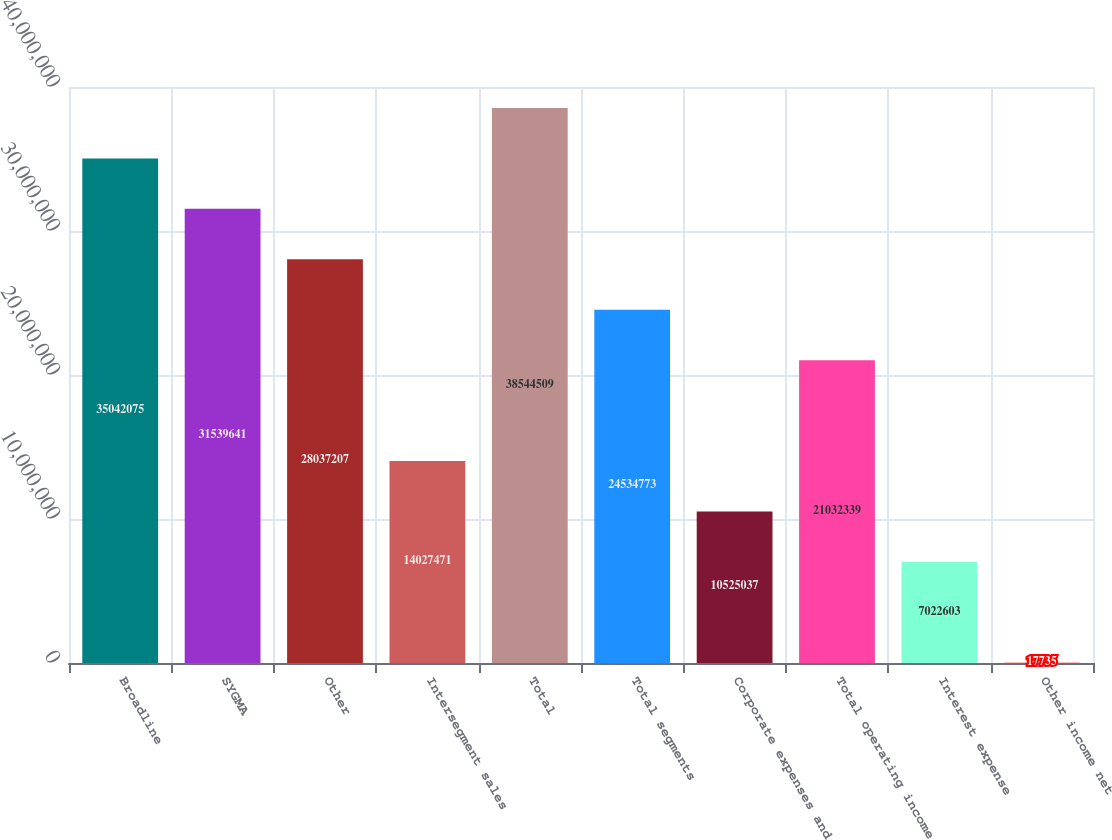<chart> <loc_0><loc_0><loc_500><loc_500><bar_chart><fcel>Broadline<fcel>SYGMA<fcel>Other<fcel>Intersegment sales<fcel>Total<fcel>Total segments<fcel>Corporate expenses and<fcel>Total operating income<fcel>Interest expense<fcel>Other income net<nl><fcel>3.50421e+07<fcel>3.15396e+07<fcel>2.80372e+07<fcel>1.40275e+07<fcel>3.85445e+07<fcel>2.45348e+07<fcel>1.0525e+07<fcel>2.10323e+07<fcel>7.0226e+06<fcel>17735<nl></chart> 